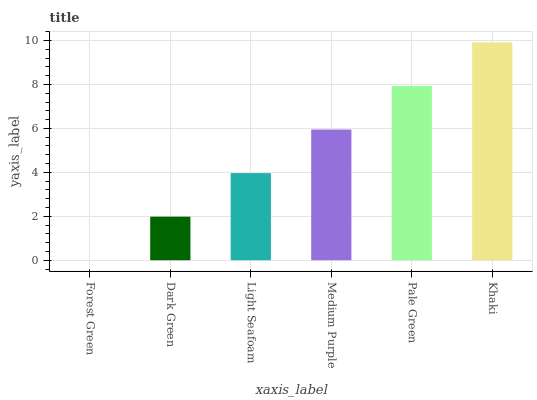Is Forest Green the minimum?
Answer yes or no. Yes. Is Khaki the maximum?
Answer yes or no. Yes. Is Dark Green the minimum?
Answer yes or no. No. Is Dark Green the maximum?
Answer yes or no. No. Is Dark Green greater than Forest Green?
Answer yes or no. Yes. Is Forest Green less than Dark Green?
Answer yes or no. Yes. Is Forest Green greater than Dark Green?
Answer yes or no. No. Is Dark Green less than Forest Green?
Answer yes or no. No. Is Medium Purple the high median?
Answer yes or no. Yes. Is Light Seafoam the low median?
Answer yes or no. Yes. Is Forest Green the high median?
Answer yes or no. No. Is Pale Green the low median?
Answer yes or no. No. 